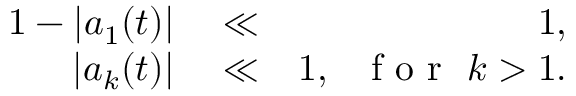<formula> <loc_0><loc_0><loc_500><loc_500>\begin{array} { r l r } { 1 - | a _ { 1 } ( t ) | } & \ll } & { 1 , } \\ { | a _ { k } ( t ) | } & \ll } & { 1 , \ \ f o r \ k > 1 . } \end{array}</formula> 